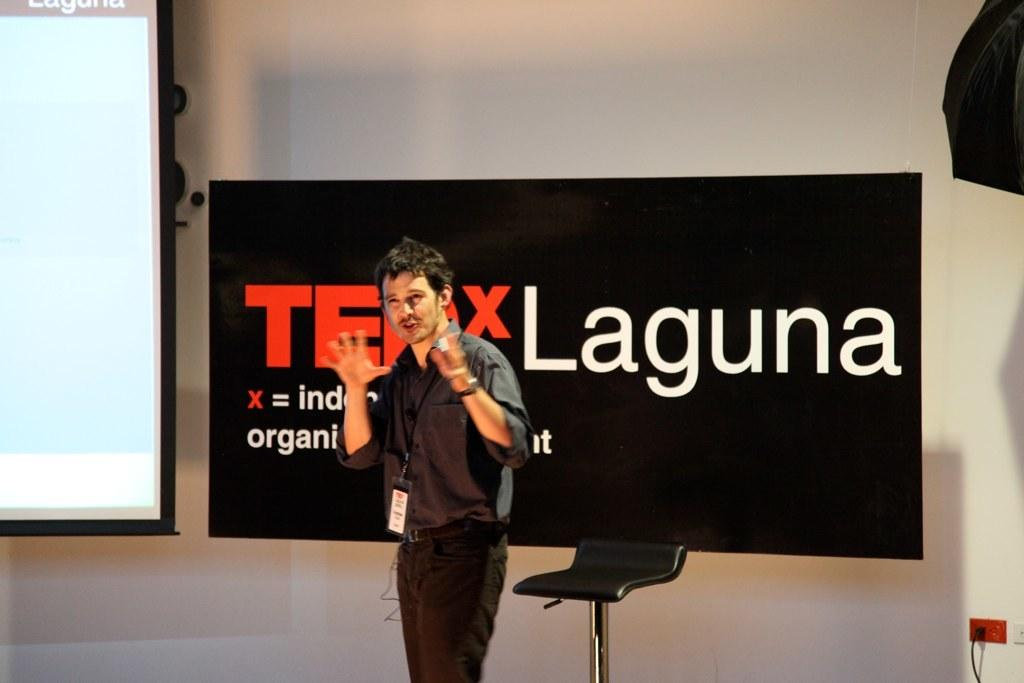Who is present in the image? There is a man in the image. What is the man doing in the image? The man is speaking in the image. What is located behind the man? There is a chair behind the man. What can be seen in the background of the image? There is a TEDx banner and a projector screen in the image. What type of tub can be seen in the image? There is no tub present in the image. How many eyes does the man have in the image? The number of eyes the man has cannot be determined from the image, as it only shows a silhouette of the man. --- Facts: 1. There is a car in the image. 2. The car is red. 3. The car has four wheels. 4. There is a road in the image. 5. The road is paved. Absurd Topics: bird, ocean, mountain Conversation: What is the main subject of the image? The main subject of the image is a car. What color is the car? The car is red. How many wheels does the car have? The car has four wheels. What type of surface can be seen in the image? There is a road in the image, and it is paved. Reasoning: Let's think step by step in order to produce the conversation. We start by identifying the main subject in the image, which is the car. Then, we describe the car's color and the number of wheels it has. Next, we mention the road in the image and its paved surface. Each question is designed to elicit a specific detail about the image that is known from the provided facts. Absurd Question/Answer: Can you see any birds flying over the ocean in the image? There is no ocean or birds present in the image; it features a red car on a paved road. What type of mountain range can be seen in the background of the image? There is no mountain range visible in the image; it only shows a red car on a paved road. 